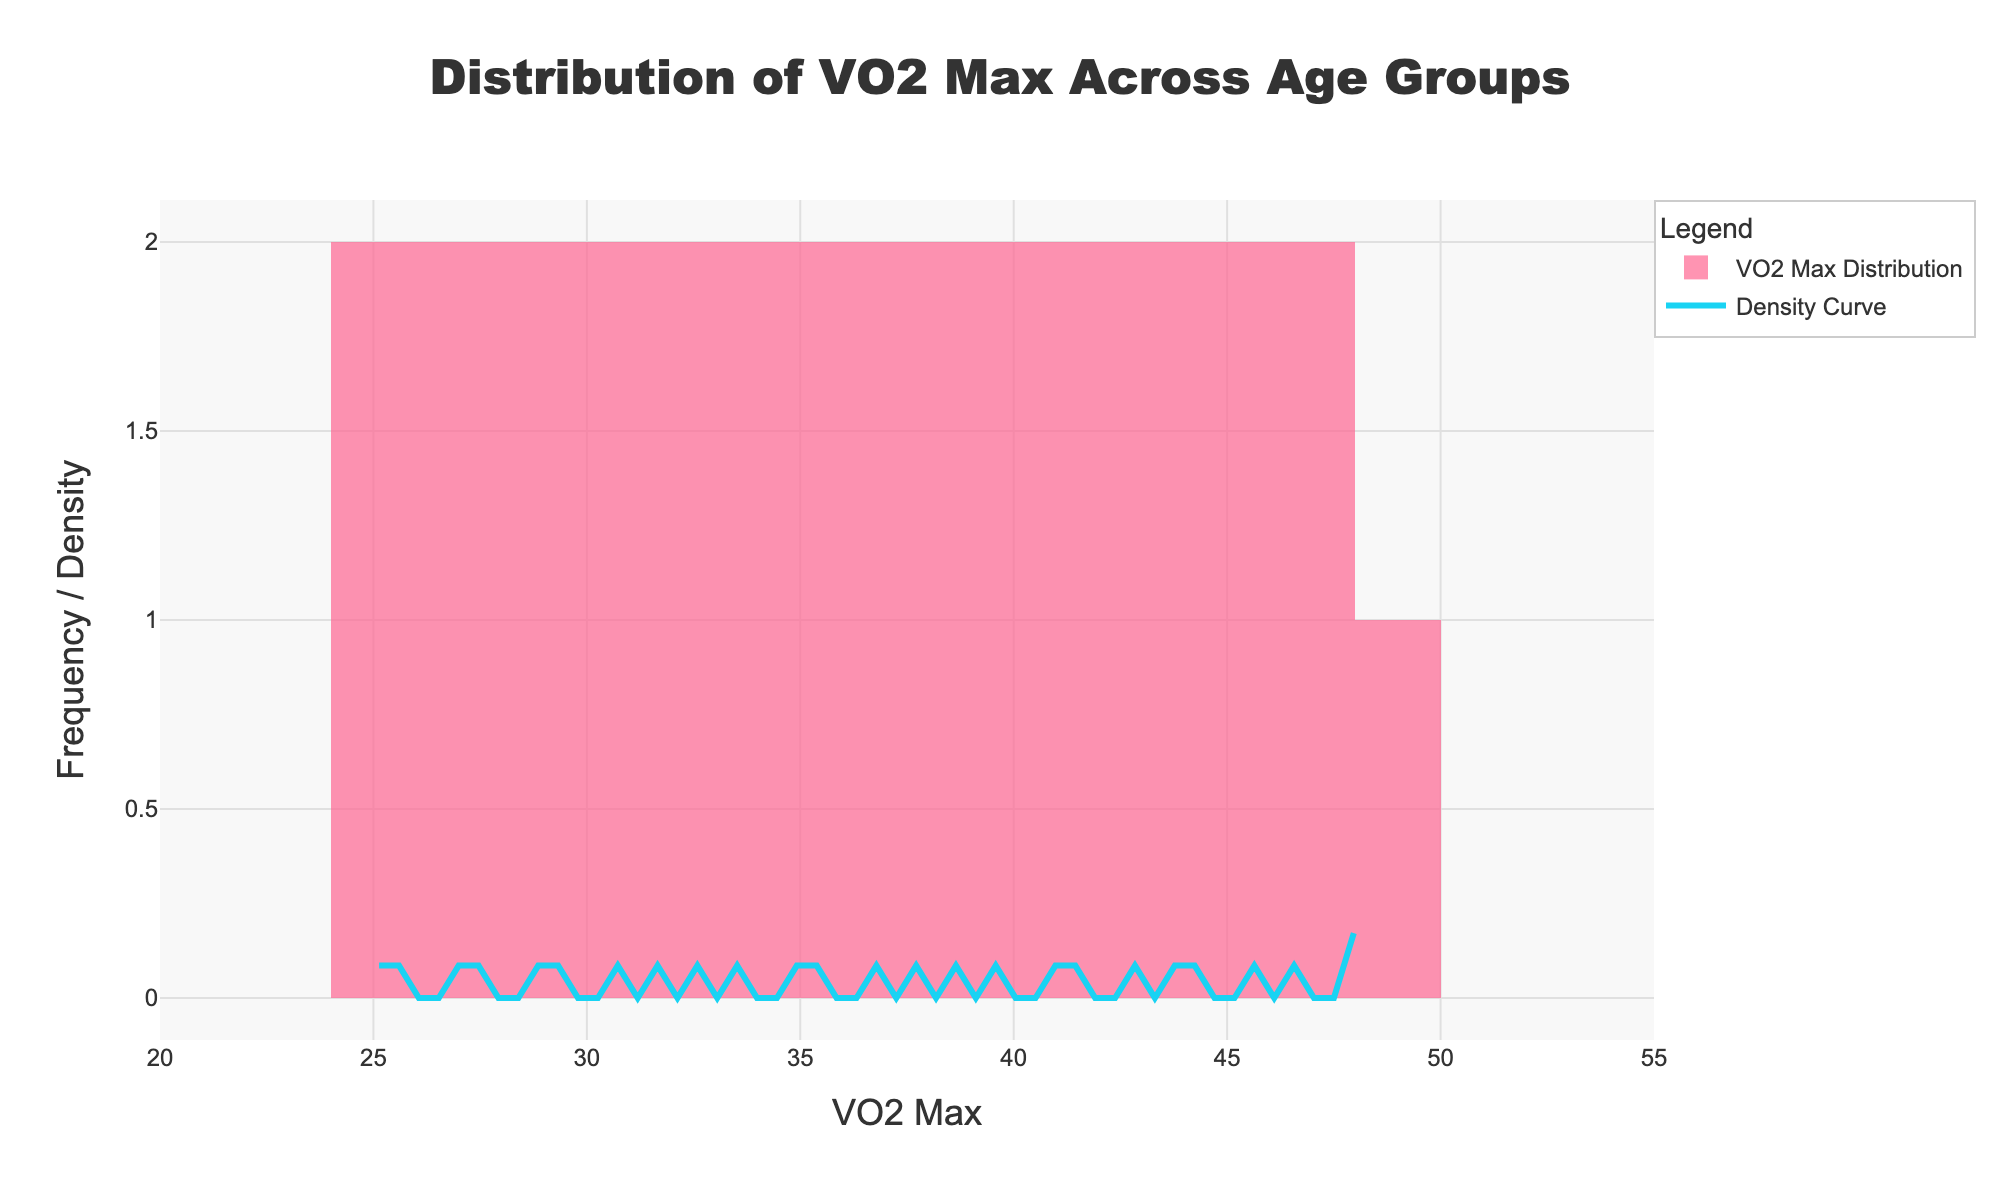What's the title of the plot? The title of the plot is usually positioned at the top and provides the main description of what the chart represents
Answer: Distribution of VO2 Max Across Age Groups What does the x-axis represent? The x-axis typically represents the variable of interest in a histogram, which in this case is mentioned in the x-axis title
Answer: VO2 Max What is the range of VO2 Max values shown on the x-axis? The x-axis range can be directly observed by looking at the minimum and maximum values marked along it.
Answer: 20 to 55 What does the y-axis represent? The y-axis is labeled to indicate what is being measured vertically, which in this case is the frequency or density of the VO2 Max values
Answer: Frequency / Density Which color represents the VO2 Max distribution in the histogram part of the plot? The visual appearance of the histogram bars indicates their color
Answer: Pink How many bins are used for the histogram? The number of bins can be counted directly in the plot or inferred from the description if it is not directly visible
Answer: 15 What does the blue line represent in the plot? The blue line corresponds to the element mentioned in the legend, which helps to identify its meaning
Answer: Density Curve Does the histogram show a higher density for lower or higher VO2 Max values? By observing the height and frequency of the bars, we can determine where the density is higher
Answer: Lower VO2 Max values What is the apparent trend in VO2 Max values across age groups? Analyzing the histogram bars distribution from left (younger age) to right (older age) reveals whether VO2 Max appears to be increasing, stable, or decreasing
Answer: Decreasing At which approximate VO2 Max value does the density curve exhibit a peak? By looking at the highest point on the blue density curve, you can identify the VO2 Max value at which the peak occurs
Answer: Around 31 